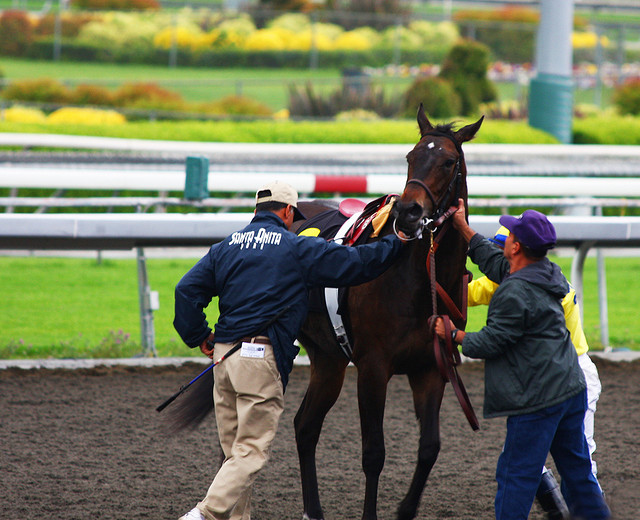Extract all visible text content from this image. SONTA ANITA 